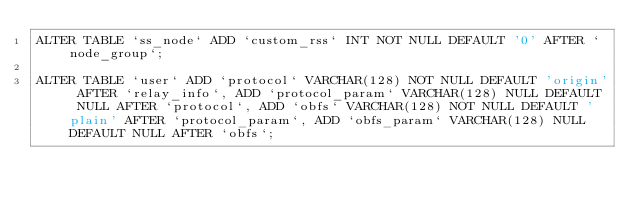<code> <loc_0><loc_0><loc_500><loc_500><_SQL_>ALTER TABLE `ss_node` ADD `custom_rss` INT NOT NULL DEFAULT '0' AFTER `node_group`;

ALTER TABLE `user` ADD `protocol` VARCHAR(128) NOT NULL DEFAULT 'origin' AFTER `relay_info`, ADD `protocol_param` VARCHAR(128) NULL DEFAULT NULL AFTER `protocol`, ADD `obfs` VARCHAR(128) NOT NULL DEFAULT 'plain' AFTER `protocol_param`, ADD `obfs_param` VARCHAR(128) NULL DEFAULT NULL AFTER `obfs`;



</code> 